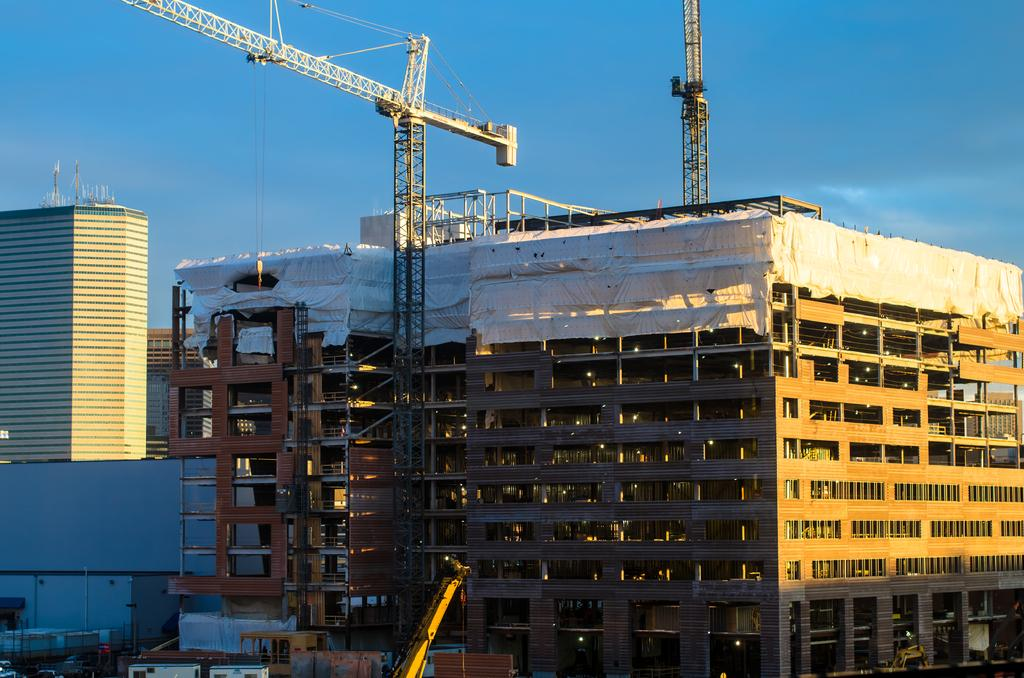What type of structures can be seen in the image? There are buildings in the image. What equipment is present in the image? There are cranes in the image. What can be seen in the distance in the image? The sky is visible in the background of the image. What type of crime is being committed in the image? There is no crime being committed in the image; it features buildings, cranes, and the sky. How many pieces of beef can be seen in the image? There is no beef present in the image. 